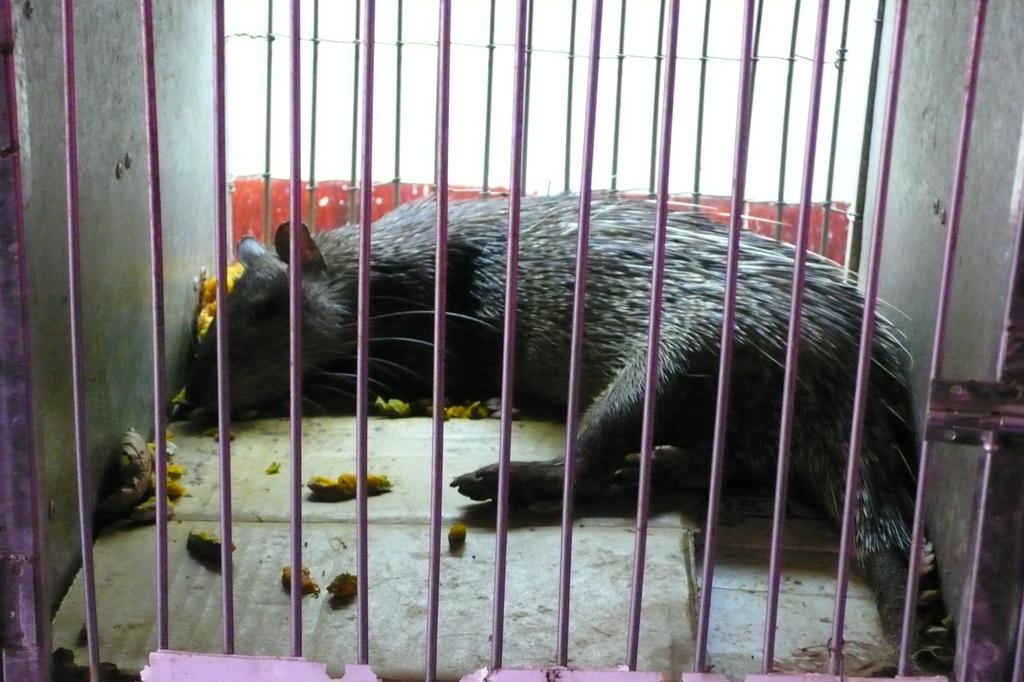What animal is present in the image? There is a rat in the image. Where is the rat located? The rat is in a cage. Can you describe any other objects or features in the image? There are some unspecified things in the image. What type of feather can be seen on the rat in the image? There is no feather present on the rat in the image. How many birds are visible in the image? There are no birds present in the image. 